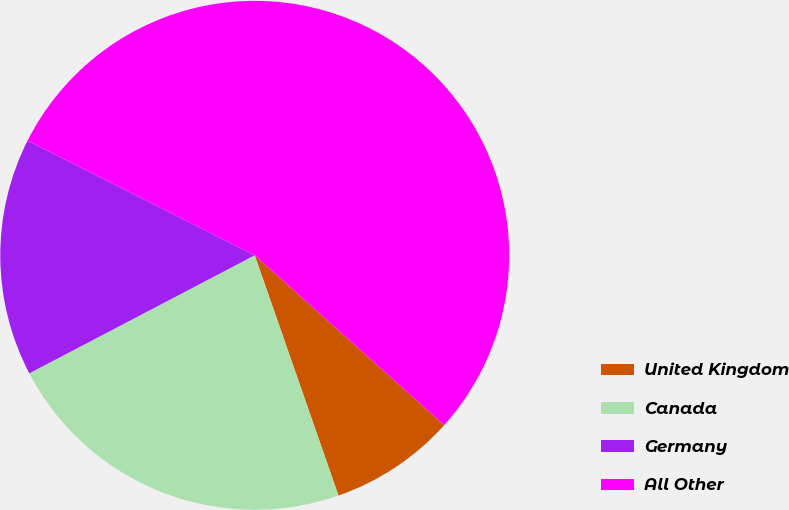<chart> <loc_0><loc_0><loc_500><loc_500><pie_chart><fcel>United Kingdom<fcel>Canada<fcel>Germany<fcel>All Other<nl><fcel>8.03%<fcel>22.66%<fcel>15.11%<fcel>54.2%<nl></chart> 